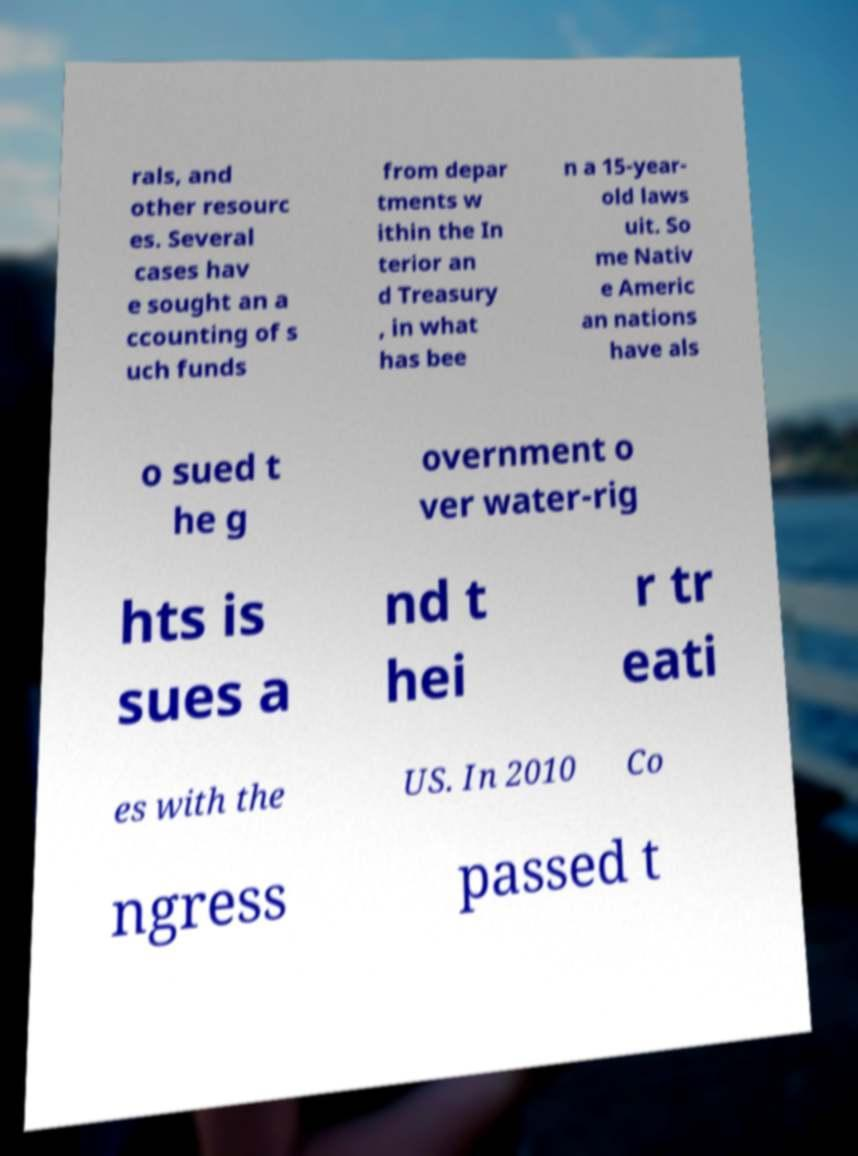Please read and relay the text visible in this image. What does it say? rals, and other resourc es. Several cases hav e sought an a ccounting of s uch funds from depar tments w ithin the In terior an d Treasury , in what has bee n a 15-year- old laws uit. So me Nativ e Americ an nations have als o sued t he g overnment o ver water-rig hts is sues a nd t hei r tr eati es with the US. In 2010 Co ngress passed t 